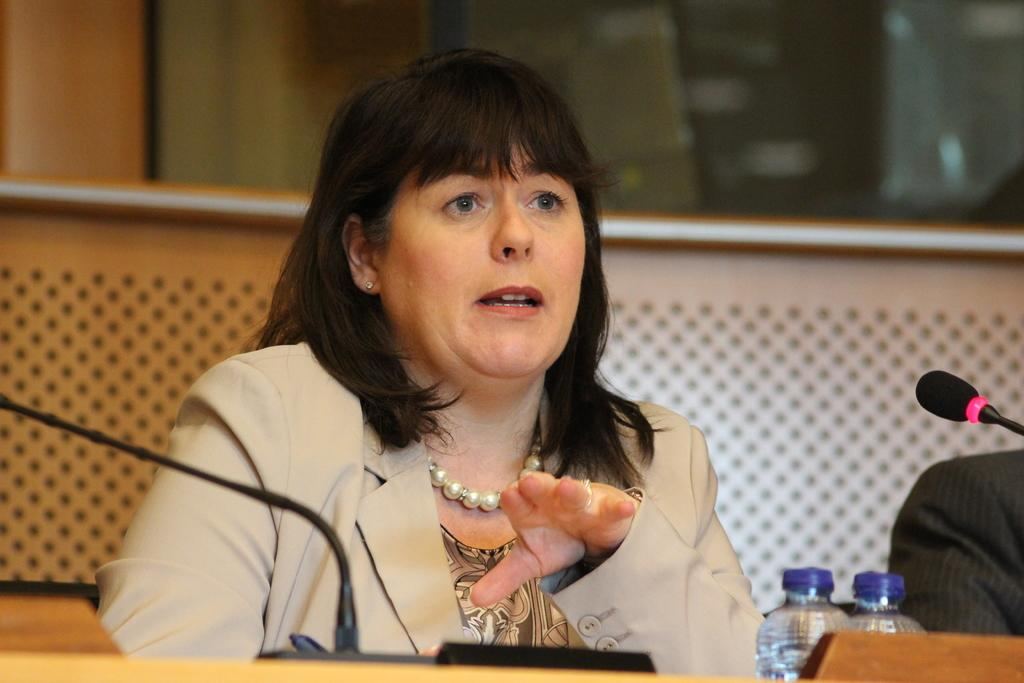How many people are in the image? There are two people in the image. What are the people doing in the image? The people are seated on chairs. What objects are in front of the people? There are microphones in front of the people. What can be seen on the table in the image? There are bottles on the table. What type of brick is being used to support the table in the image? There is no brick present in the image, and the table is not supported by a brick. 